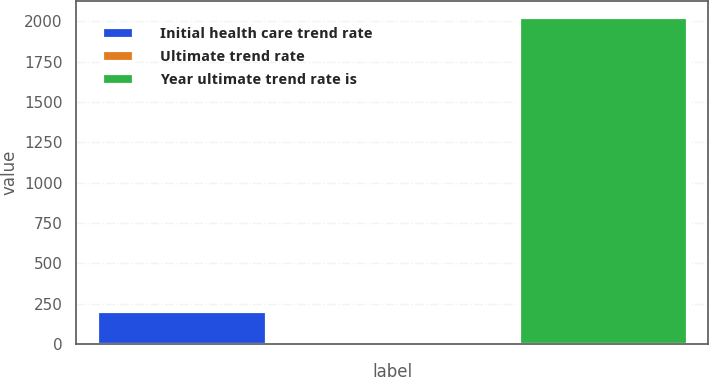Convert chart. <chart><loc_0><loc_0><loc_500><loc_500><bar_chart><fcel>Initial health care trend rate<fcel>Ultimate trend rate<fcel>Year ultimate trend rate is<nl><fcel>206.55<fcel>4.5<fcel>2025<nl></chart> 